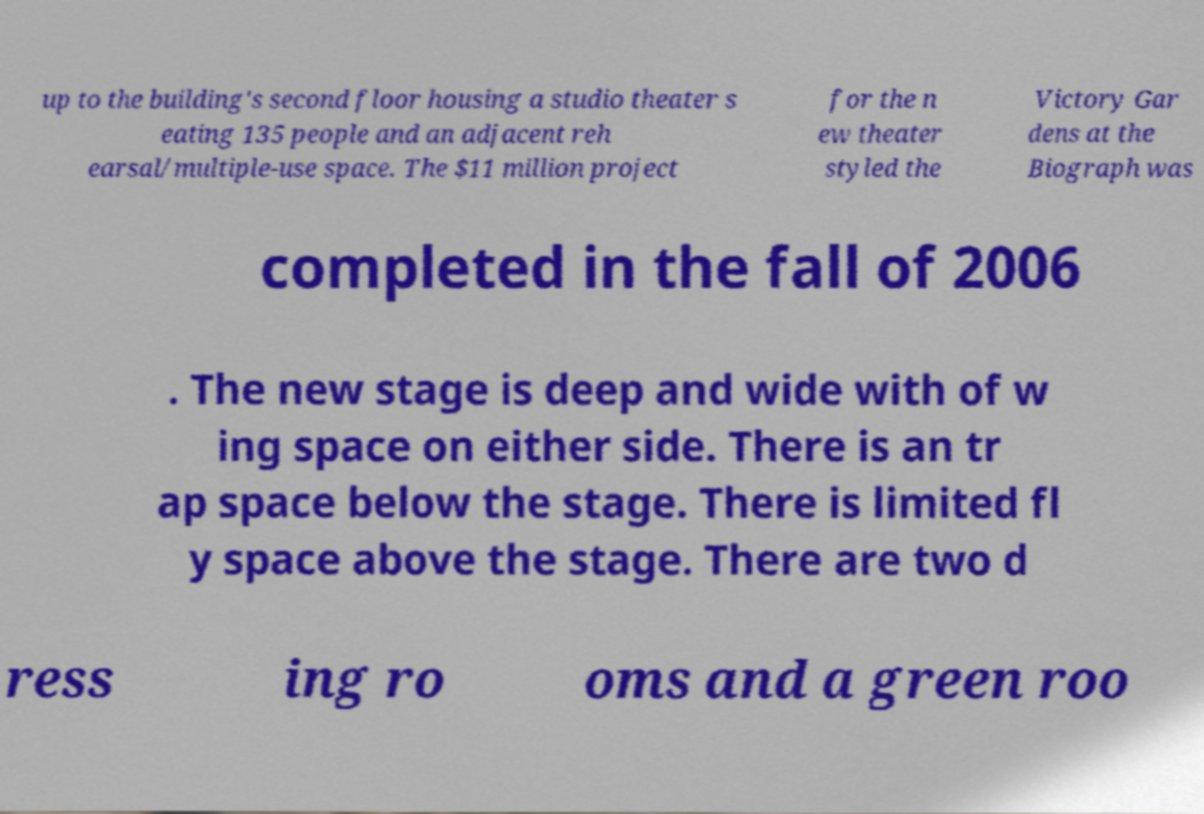For documentation purposes, I need the text within this image transcribed. Could you provide that? up to the building's second floor housing a studio theater s eating 135 people and an adjacent reh earsal/multiple-use space. The $11 million project for the n ew theater styled the Victory Gar dens at the Biograph was completed in the fall of 2006 . The new stage is deep and wide with of w ing space on either side. There is an tr ap space below the stage. There is limited fl y space above the stage. There are two d ress ing ro oms and a green roo 